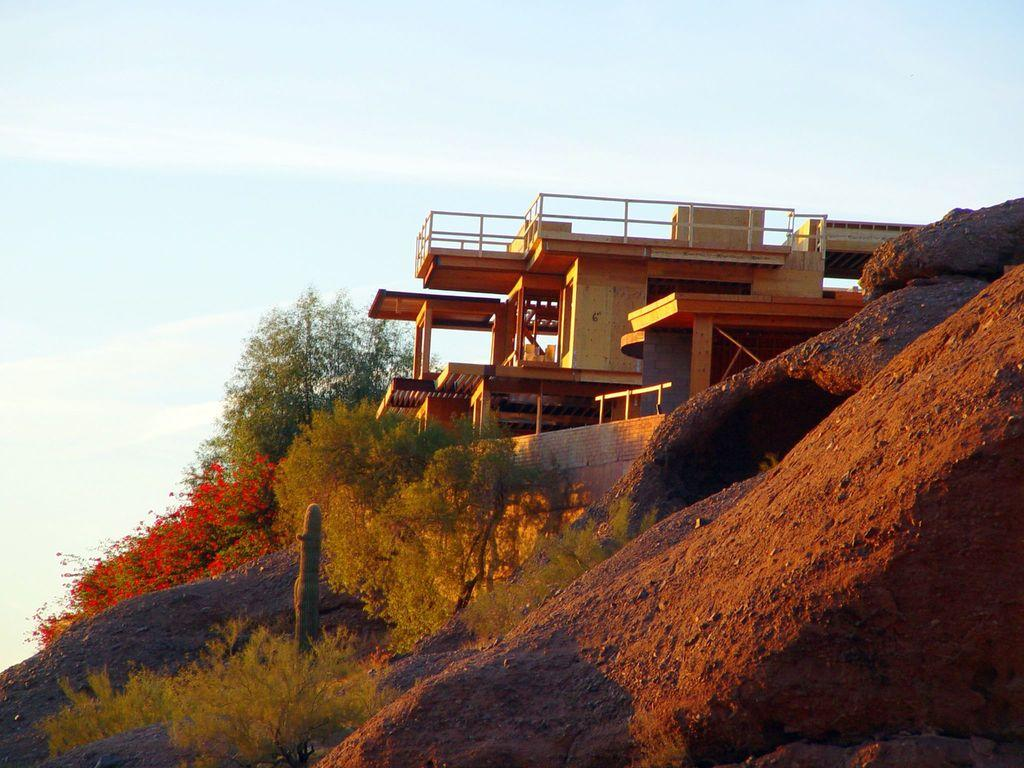What type of structure is located on the right side of the image? There is a building with pillars and railings on the right side of the image. What can be seen near the building? There are trees and flowers near the building. What is the terrain like in the image? There is a small hill in the image. What is visible in the background of the image? The sky is visible in the background of the image. What type of pest can be seen crawling on the building in the image? There is no pest visible on the building in the image. How does the engine of the building work in the image? The image does not depict an engine or any machinery; it is a static representation of a building with pillars and railings. 